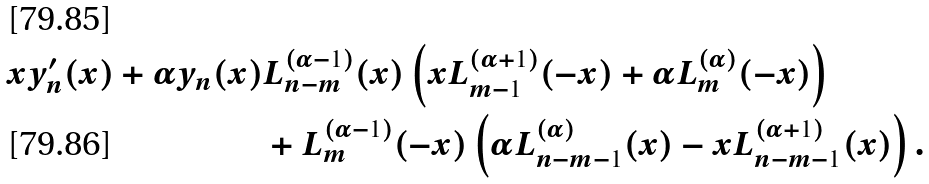Convert formula to latex. <formula><loc_0><loc_0><loc_500><loc_500>x y _ { n } ^ { \prime } ( x ) + \alpha y _ { n } ( x ) & L _ { n - m } ^ { ( \alpha - 1 ) } ( x ) \left ( x L _ { m - 1 } ^ { ( \alpha + 1 ) } ( - x ) + \alpha L _ { m } ^ { ( \alpha ) } ( - x ) \right ) \\ & + L _ { m } ^ { ( \alpha - 1 ) } ( - x ) \left ( \alpha L _ { n - m - 1 } ^ { ( \alpha ) } ( x ) - x L _ { n - m - 1 } ^ { ( \alpha + 1 ) } ( x ) \right ) .</formula> 